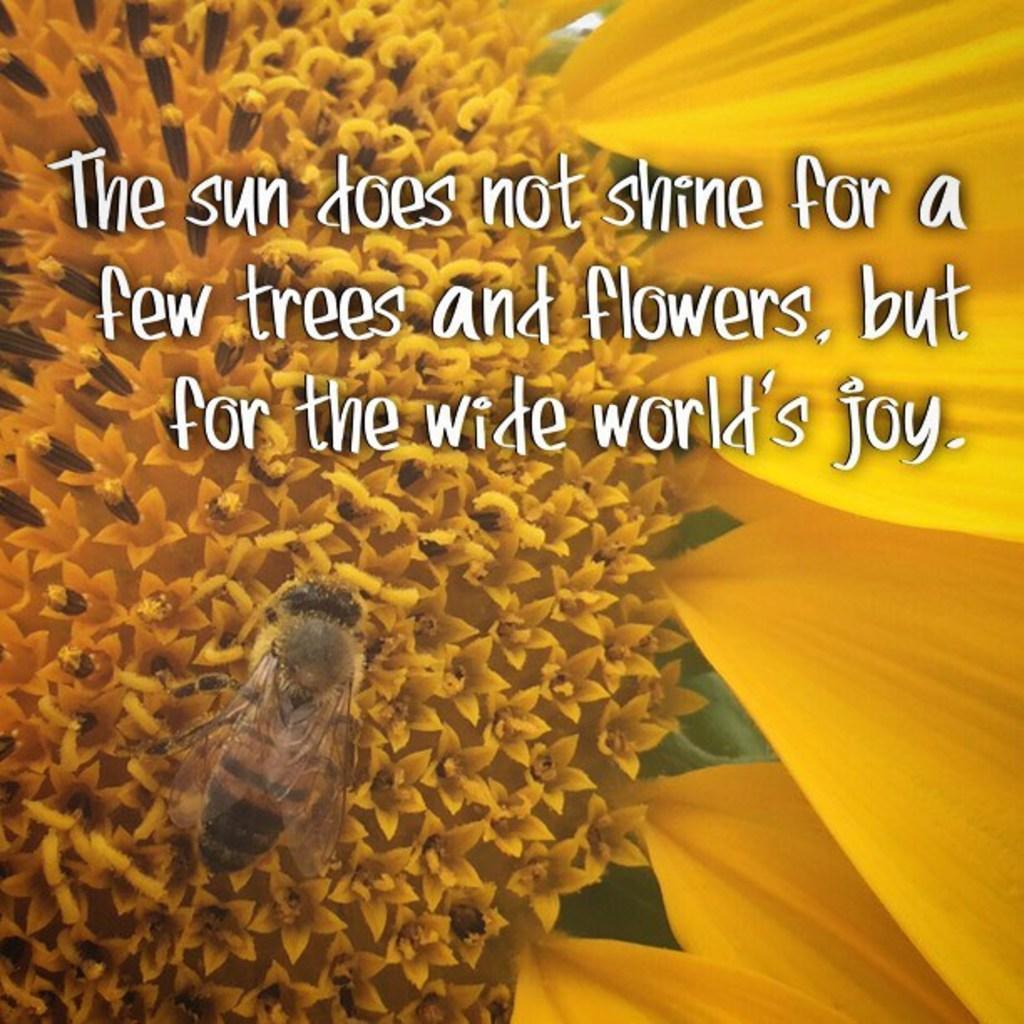Please provide a concise description of this image. In this image we can see many flowers. We can see an insect. There is some text in the image. 